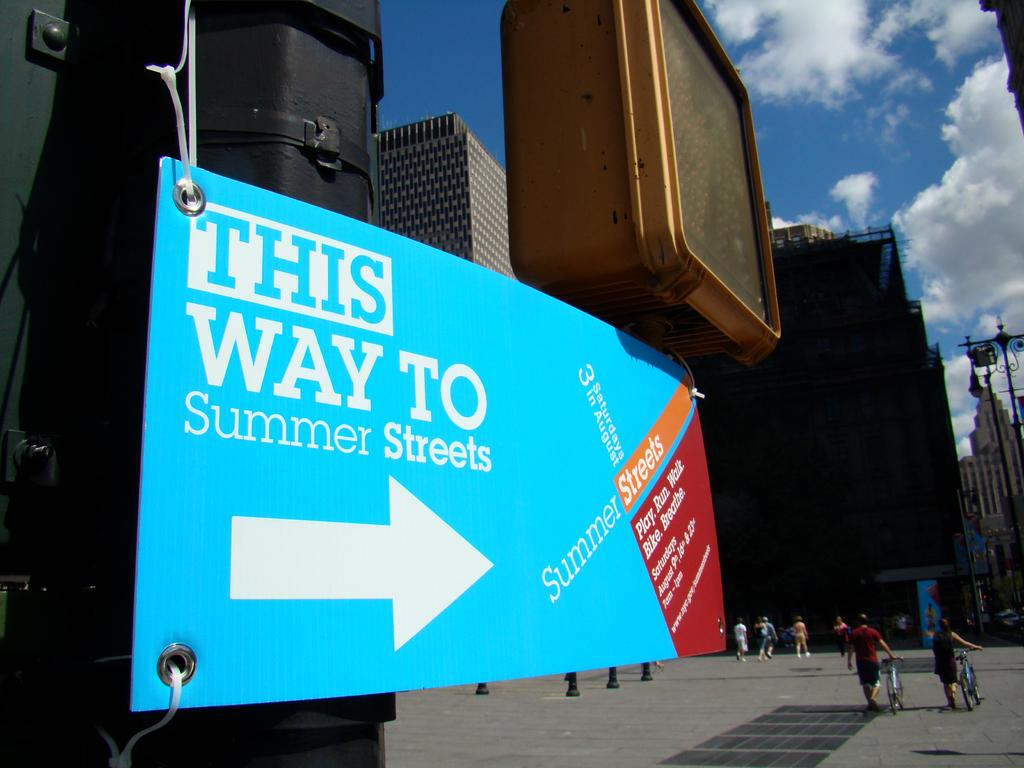<image>
Create a compact narrative representing the image presented. A bright blue sign on a light post say This way to summer streets 